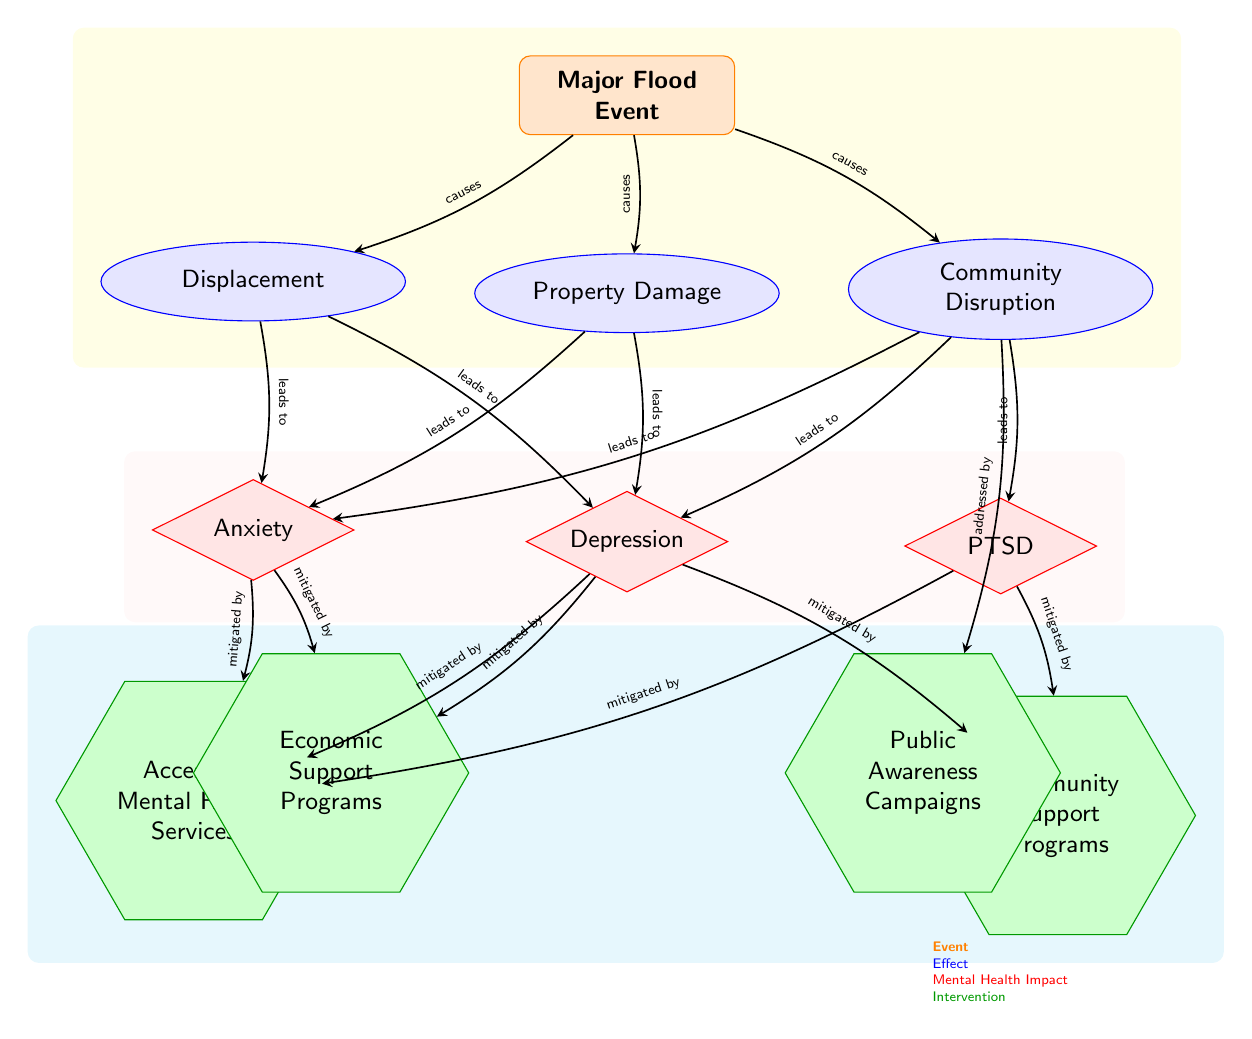What is the main event depicted in the diagram? The main event is labeled as "Major Flood Event" at the top of the diagram.
Answer: Major Flood Event How many mental health impacts are indicated? There are three mental health impacts listed: Anxiety, Depression, and PTSD, located below the effects of the flood.
Answer: 3 What type of relationship exists between "Community Disruption" and "PTSD"? The relationship is indicated as "leads to", showing that Community Disruption leads to PTSD.
Answer: leads to Which intervention addresses community disruption? The intervention that addresses community disruption is "Public Awareness Campaigns", as indicated by the connection from the community node to the awareness intervention.
Answer: Public Awareness Campaigns How many nodes are categorized as interventions? There are four nodes categorized as interventions: Access to Mental Health Services, Community Support Programs, Economic Support Programs, and Public Awareness Campaigns.
Answer: 4 What can mitigate anxiety according to the diagram? Anxiety can be mitigated by Access to Mental Health Services and Economic Support Programs as shown by the arrows leading from those intervention nodes.
Answer: Access to Mental Health Services, Economic Support Programs What is the effect of displacement caused by a major flood event? The effects of displacement include increasing levels of Anxiety and Depression as indicated by the arrows pointing from displacement to these mental health impacts.
Answer: Anxiety, Depression Which type of node is represented by the term "PTSD"? "PTSD" is represented by a diamond-shaped node, indicating it is categorized as a mental health impact.
Answer: diamond Which colored nodes represent effects in the diagram? The nodes representing effects are colored blue, specifically indicating Property Damage, Community Disruption, and Displacement.
Answer: blue 